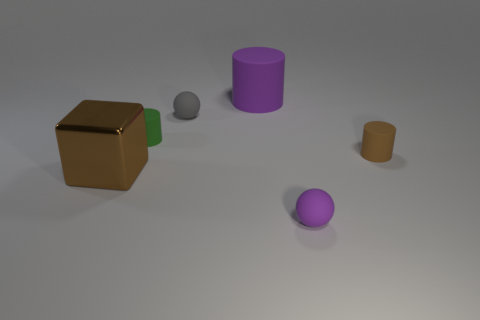Subtract all green cylinders. How many cylinders are left? 2 Add 1 gray balls. How many objects exist? 7 Subtract all green cylinders. How many cylinders are left? 2 Subtract all balls. How many objects are left? 4 Subtract 1 blocks. How many blocks are left? 0 Subtract all purple balls. Subtract all gray cubes. How many balls are left? 1 Subtract all big purple shiny objects. Subtract all big brown metal objects. How many objects are left? 5 Add 5 big brown cubes. How many big brown cubes are left? 6 Add 4 tiny brown cylinders. How many tiny brown cylinders exist? 5 Subtract 0 yellow cubes. How many objects are left? 6 